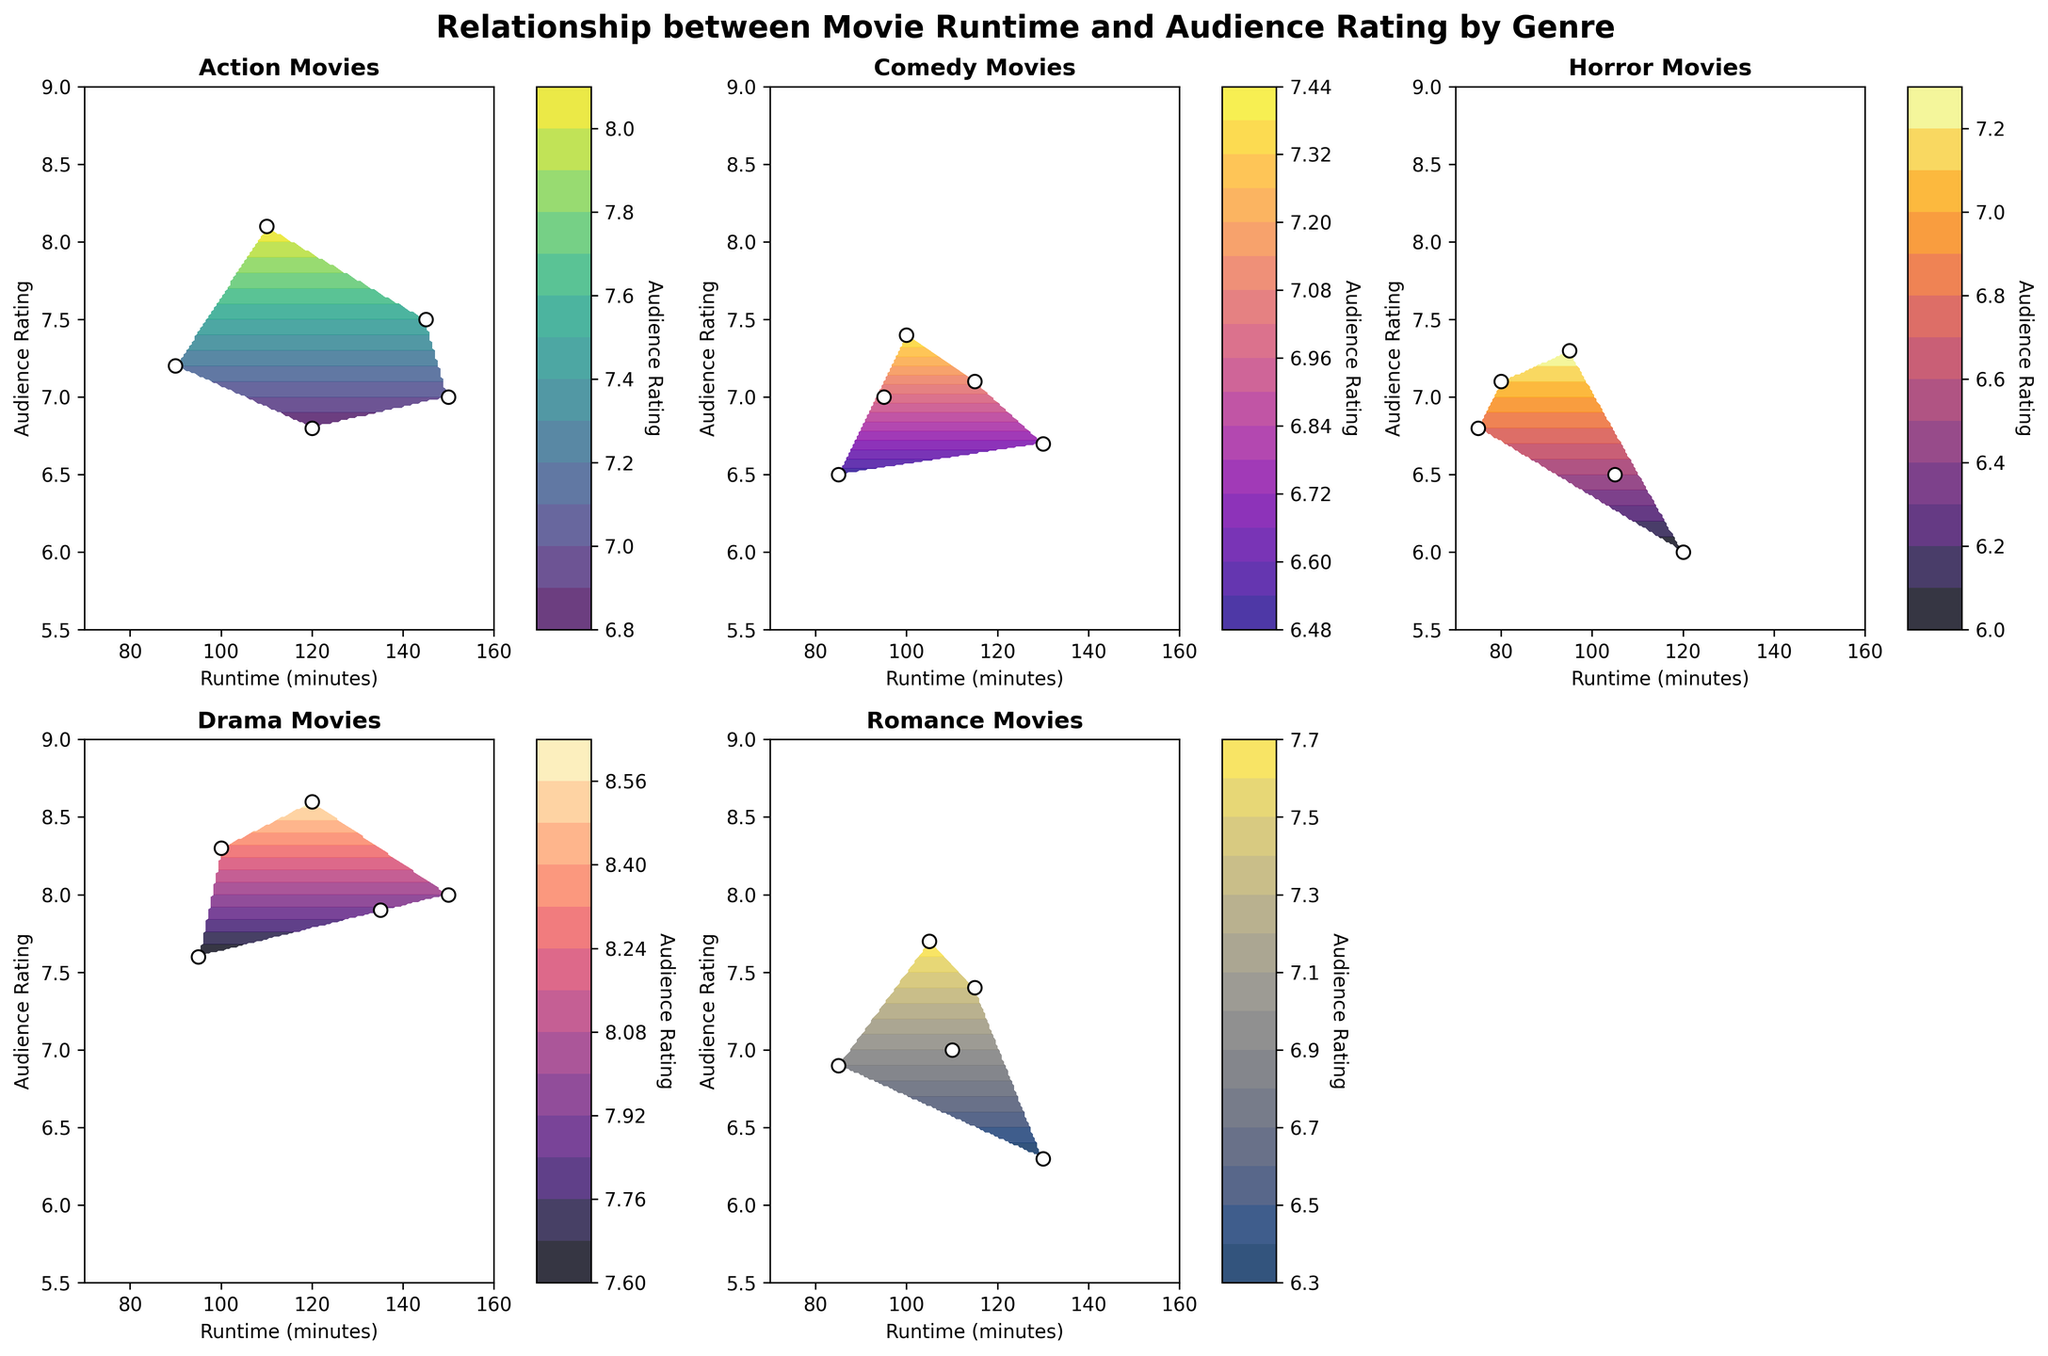What genres are compared in the figure? The figure compares five genres which are mentioned in separate plots: Action, Comedy, Horror, Drama, and Romance. Each subplot title specifies a different genre.
Answer: Action, Comedy, Horror, Drama, Romance Which genre has the highest audience rating based on the contour plot? By observing the highest rating peaks across all subplots, the audience rating for Drama appears higher, especially around the 8.6 mark.
Answer: Drama What is the general trend of Action movies in terms of runtime and audience satisfaction? Most Action movies seem to cluster between 7.0 and 8.1 ratings with runtimes between 90 and 150 minutes. The trend suggests a slight decrease in satisfaction as runtime increases.
Answer: Slight decrease with longer runtime Which genre shows the greatest variation in audience ratings? The Comedy and Romance genres have relatively diverse points spread across the y-axis (audience rating). However, Romance particularly shows a wide range with ratings between 6.3 and 7.7.
Answer: Romance Between Horror and Comedy, which genre's movies appear more consistent in terms of audience ratings? Horror movies have ratings that vary between 6.0 and 7.3, while Comedy movies' ratings vary between 6.5 and 7.4. The smaller variation in Horror (6.5 to 7.3) indicates more consistency.
Answer: Horror Do longer movies tend to have better ratings in the Drama genre? By looking at Drama's subplot, movies with runtimes from 120 to 150 minutes mostly have ratings above 7.5, which implies longer Drama movies generally have better ratings.
Answer: Yes Is there any genre where shorter movies (<100 minutes) often have better ratings than their longer counterparts? Comedy and Romance genres show some shorter movies below 100 minutes with higher ratings around the 7 to 7.7 mark compared to some longer movies with lower ratings.
Answer: Yes, Comedy and Romance Which genres have outlier audience ratings, either very high or very low compared to their typical range? For instance, Drama has an outlier rating at 8.6 and Horror has a notably low rating at 6.0, differing from their typical range of audience ratings.
Answer: Drama (high), Horror (low) Are there any genres where movies longer than 130 minutes have consistently low ratings? Both Romance and Horror genres show movies longer than 130 minutes with consistently lower ratings compared to the rest of their runtime.
Answer: Romance, Horror What pattern emerges in the subplots for the highest-rated movies within each genre? The highest ratings in each genre often occur in a specific runtime range: Action (~110-145 min), Comedy (~95-100 min), Horror (~95 min), Drama (~120-150 min), and Romance (~105 min). These peaks suggest optimal lengths for high ratings in each genre.
Answer: Specific runtime peaks for high ratings 